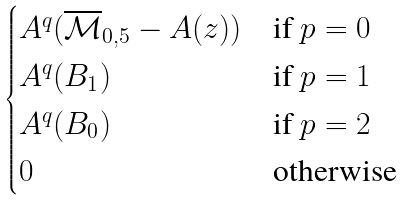<formula> <loc_0><loc_0><loc_500><loc_500>\begin{cases} A ^ { q } ( \overline { \mathcal { M } } _ { 0 , 5 } - A ( z ) ) & \text {if $p=0$} \\ A ^ { q } ( B _ { 1 } ) & \text {if $p=1$} \\ A ^ { q } ( B _ { 0 } ) & \text {if $p=2$} \\ 0 & \text {otherwise} \end{cases}</formula> 